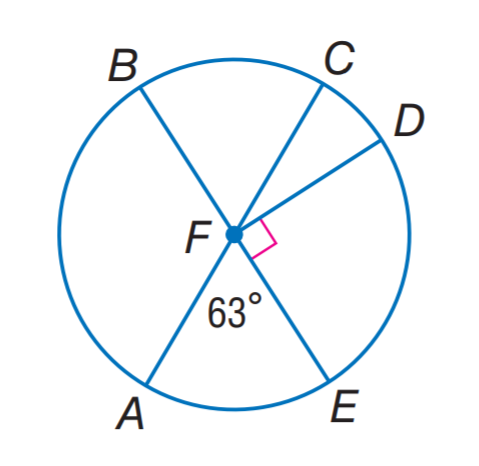Answer the mathemtical geometry problem and directly provide the correct option letter.
Question: In \odot F, find m \widehat A E D.
Choices: A: 63 B: 93 C: 123 D: 153 D 